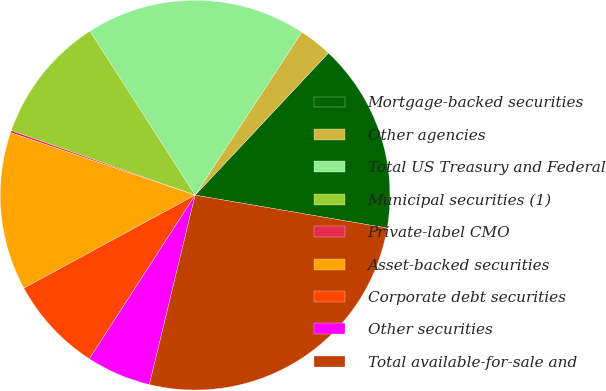Convert chart. <chart><loc_0><loc_0><loc_500><loc_500><pie_chart><fcel>Mortgage-backed securities<fcel>Other agencies<fcel>Total US Treasury and Federal<fcel>Municipal securities (1)<fcel>Private-label CMO<fcel>Asset-backed securities<fcel>Corporate debt securities<fcel>Other securities<fcel>Total available-for-sale and<nl><fcel>15.71%<fcel>2.77%<fcel>18.3%<fcel>10.54%<fcel>0.18%<fcel>13.12%<fcel>7.95%<fcel>5.36%<fcel>26.07%<nl></chart> 